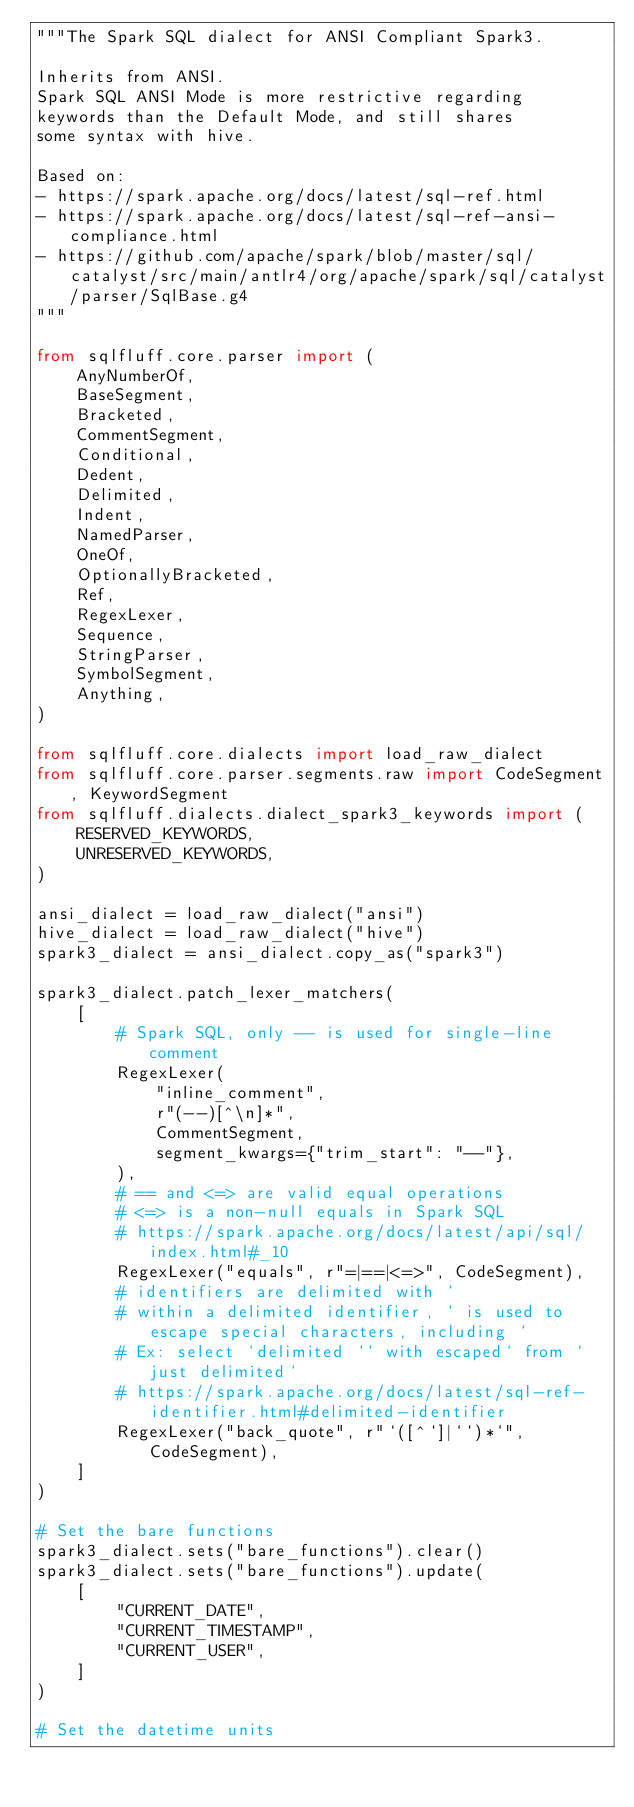Convert code to text. <code><loc_0><loc_0><loc_500><loc_500><_Python_>"""The Spark SQL dialect for ANSI Compliant Spark3.

Inherits from ANSI.
Spark SQL ANSI Mode is more restrictive regarding
keywords than the Default Mode, and still shares
some syntax with hive.

Based on:
- https://spark.apache.org/docs/latest/sql-ref.html
- https://spark.apache.org/docs/latest/sql-ref-ansi-compliance.html
- https://github.com/apache/spark/blob/master/sql/catalyst/src/main/antlr4/org/apache/spark/sql/catalyst/parser/SqlBase.g4
"""

from sqlfluff.core.parser import (
    AnyNumberOf,
    BaseSegment,
    Bracketed,
    CommentSegment,
    Conditional,
    Dedent,
    Delimited,
    Indent,
    NamedParser,
    OneOf,
    OptionallyBracketed,
    Ref,
    RegexLexer,
    Sequence,
    StringParser,
    SymbolSegment,
    Anything,
)

from sqlfluff.core.dialects import load_raw_dialect
from sqlfluff.core.parser.segments.raw import CodeSegment, KeywordSegment
from sqlfluff.dialects.dialect_spark3_keywords import (
    RESERVED_KEYWORDS,
    UNRESERVED_KEYWORDS,
)

ansi_dialect = load_raw_dialect("ansi")
hive_dialect = load_raw_dialect("hive")
spark3_dialect = ansi_dialect.copy_as("spark3")

spark3_dialect.patch_lexer_matchers(
    [
        # Spark SQL, only -- is used for single-line comment
        RegexLexer(
            "inline_comment",
            r"(--)[^\n]*",
            CommentSegment,
            segment_kwargs={"trim_start": "--"},
        ),
        # == and <=> are valid equal operations
        # <=> is a non-null equals in Spark SQL
        # https://spark.apache.org/docs/latest/api/sql/index.html#_10
        RegexLexer("equals", r"=|==|<=>", CodeSegment),
        # identifiers are delimited with `
        # within a delimited identifier, ` is used to escape special characters, including `
        # Ex: select `delimited `` with escaped` from `just delimited`
        # https://spark.apache.org/docs/latest/sql-ref-identifier.html#delimited-identifier
        RegexLexer("back_quote", r"`([^`]|``)*`", CodeSegment),
    ]
)

# Set the bare functions
spark3_dialect.sets("bare_functions").clear()
spark3_dialect.sets("bare_functions").update(
    [
        "CURRENT_DATE",
        "CURRENT_TIMESTAMP",
        "CURRENT_USER",
    ]
)

# Set the datetime units</code> 